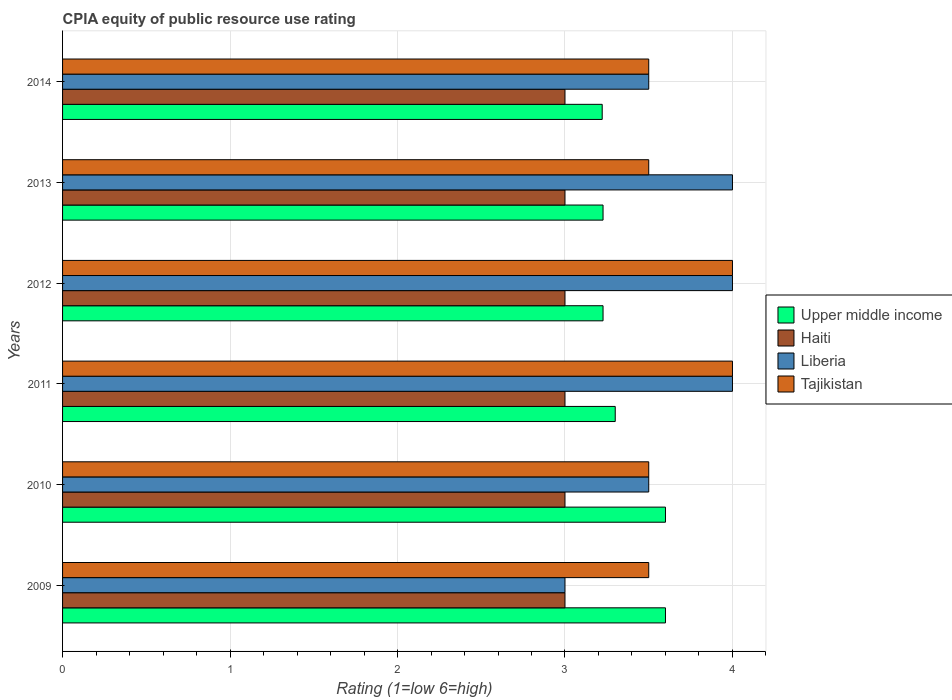How many different coloured bars are there?
Offer a very short reply. 4. How many groups of bars are there?
Ensure brevity in your answer.  6. Are the number of bars per tick equal to the number of legend labels?
Offer a very short reply. Yes. Are the number of bars on each tick of the Y-axis equal?
Your answer should be compact. Yes. How many bars are there on the 5th tick from the top?
Ensure brevity in your answer.  4. How many bars are there on the 2nd tick from the bottom?
Your answer should be very brief. 4. What is the CPIA rating in Tajikistan in 2012?
Provide a succinct answer. 4. Across all years, what is the maximum CPIA rating in Upper middle income?
Ensure brevity in your answer.  3.6. Across all years, what is the minimum CPIA rating in Upper middle income?
Your response must be concise. 3.22. In which year was the CPIA rating in Haiti maximum?
Make the answer very short. 2009. What is the total CPIA rating in Liberia in the graph?
Your answer should be very brief. 22. What is the difference between the CPIA rating in Upper middle income in 2013 and that in 2014?
Offer a terse response. 0.01. In the year 2011, what is the difference between the CPIA rating in Haiti and CPIA rating in Upper middle income?
Offer a very short reply. -0.3. In how many years, is the CPIA rating in Upper middle income greater than 3.6 ?
Keep it short and to the point. 0. What is the ratio of the CPIA rating in Upper middle income in 2012 to that in 2013?
Offer a terse response. 1. Is the CPIA rating in Upper middle income in 2011 less than that in 2012?
Offer a terse response. No. What is the difference between the highest and the second highest CPIA rating in Tajikistan?
Ensure brevity in your answer.  0. What is the difference between the highest and the lowest CPIA rating in Upper middle income?
Your response must be concise. 0.38. In how many years, is the CPIA rating in Tajikistan greater than the average CPIA rating in Tajikistan taken over all years?
Your response must be concise. 2. Is the sum of the CPIA rating in Tajikistan in 2010 and 2011 greater than the maximum CPIA rating in Liberia across all years?
Offer a very short reply. Yes. Is it the case that in every year, the sum of the CPIA rating in Tajikistan and CPIA rating in Liberia is greater than the sum of CPIA rating in Upper middle income and CPIA rating in Haiti?
Offer a very short reply. No. What does the 4th bar from the top in 2013 represents?
Provide a short and direct response. Upper middle income. What does the 2nd bar from the bottom in 2011 represents?
Provide a succinct answer. Haiti. How many years are there in the graph?
Offer a very short reply. 6. Does the graph contain any zero values?
Provide a short and direct response. No. Does the graph contain grids?
Offer a terse response. Yes. Where does the legend appear in the graph?
Your response must be concise. Center right. How many legend labels are there?
Give a very brief answer. 4. How are the legend labels stacked?
Offer a very short reply. Vertical. What is the title of the graph?
Ensure brevity in your answer.  CPIA equity of public resource use rating. Does "Europe(all income levels)" appear as one of the legend labels in the graph?
Offer a very short reply. No. What is the label or title of the X-axis?
Ensure brevity in your answer.  Rating (1=low 6=high). What is the label or title of the Y-axis?
Your answer should be very brief. Years. What is the Rating (1=low 6=high) in Upper middle income in 2009?
Give a very brief answer. 3.6. What is the Rating (1=low 6=high) in Haiti in 2009?
Offer a terse response. 3. What is the Rating (1=low 6=high) of Liberia in 2009?
Make the answer very short. 3. What is the Rating (1=low 6=high) in Tajikistan in 2009?
Your answer should be very brief. 3.5. What is the Rating (1=low 6=high) of Haiti in 2010?
Your response must be concise. 3. What is the Rating (1=low 6=high) of Liberia in 2010?
Offer a terse response. 3.5. What is the Rating (1=low 6=high) of Tajikistan in 2010?
Offer a terse response. 3.5. What is the Rating (1=low 6=high) of Tajikistan in 2011?
Offer a very short reply. 4. What is the Rating (1=low 6=high) of Upper middle income in 2012?
Offer a terse response. 3.23. What is the Rating (1=low 6=high) of Tajikistan in 2012?
Your answer should be very brief. 4. What is the Rating (1=low 6=high) of Upper middle income in 2013?
Offer a very short reply. 3.23. What is the Rating (1=low 6=high) of Liberia in 2013?
Offer a terse response. 4. What is the Rating (1=low 6=high) in Tajikistan in 2013?
Ensure brevity in your answer.  3.5. What is the Rating (1=low 6=high) of Upper middle income in 2014?
Keep it short and to the point. 3.22. What is the Rating (1=low 6=high) in Haiti in 2014?
Your answer should be compact. 3. Across all years, what is the maximum Rating (1=low 6=high) in Upper middle income?
Give a very brief answer. 3.6. Across all years, what is the maximum Rating (1=low 6=high) in Haiti?
Give a very brief answer. 3. Across all years, what is the maximum Rating (1=low 6=high) of Liberia?
Ensure brevity in your answer.  4. Across all years, what is the maximum Rating (1=low 6=high) in Tajikistan?
Ensure brevity in your answer.  4. Across all years, what is the minimum Rating (1=low 6=high) of Upper middle income?
Your answer should be compact. 3.22. Across all years, what is the minimum Rating (1=low 6=high) of Liberia?
Give a very brief answer. 3. Across all years, what is the minimum Rating (1=low 6=high) in Tajikistan?
Provide a short and direct response. 3.5. What is the total Rating (1=low 6=high) of Upper middle income in the graph?
Keep it short and to the point. 20.18. What is the total Rating (1=low 6=high) in Tajikistan in the graph?
Provide a succinct answer. 22. What is the difference between the Rating (1=low 6=high) in Upper middle income in 2009 and that in 2010?
Give a very brief answer. 0. What is the difference between the Rating (1=low 6=high) in Tajikistan in 2009 and that in 2010?
Your response must be concise. 0. What is the difference between the Rating (1=low 6=high) of Upper middle income in 2009 and that in 2011?
Keep it short and to the point. 0.3. What is the difference between the Rating (1=low 6=high) of Haiti in 2009 and that in 2011?
Keep it short and to the point. 0. What is the difference between the Rating (1=low 6=high) in Liberia in 2009 and that in 2011?
Your answer should be compact. -1. What is the difference between the Rating (1=low 6=high) in Tajikistan in 2009 and that in 2011?
Your answer should be compact. -0.5. What is the difference between the Rating (1=low 6=high) in Upper middle income in 2009 and that in 2012?
Provide a succinct answer. 0.37. What is the difference between the Rating (1=low 6=high) of Haiti in 2009 and that in 2012?
Ensure brevity in your answer.  0. What is the difference between the Rating (1=low 6=high) in Liberia in 2009 and that in 2012?
Offer a terse response. -1. What is the difference between the Rating (1=low 6=high) of Tajikistan in 2009 and that in 2012?
Provide a succinct answer. -0.5. What is the difference between the Rating (1=low 6=high) in Upper middle income in 2009 and that in 2013?
Keep it short and to the point. 0.37. What is the difference between the Rating (1=low 6=high) in Haiti in 2009 and that in 2013?
Your answer should be very brief. 0. What is the difference between the Rating (1=low 6=high) in Liberia in 2009 and that in 2013?
Your response must be concise. -1. What is the difference between the Rating (1=low 6=high) in Tajikistan in 2009 and that in 2013?
Your response must be concise. 0. What is the difference between the Rating (1=low 6=high) of Upper middle income in 2009 and that in 2014?
Make the answer very short. 0.38. What is the difference between the Rating (1=low 6=high) of Tajikistan in 2009 and that in 2014?
Your response must be concise. 0. What is the difference between the Rating (1=low 6=high) in Haiti in 2010 and that in 2011?
Provide a short and direct response. 0. What is the difference between the Rating (1=low 6=high) in Liberia in 2010 and that in 2011?
Your response must be concise. -0.5. What is the difference between the Rating (1=low 6=high) of Tajikistan in 2010 and that in 2011?
Give a very brief answer. -0.5. What is the difference between the Rating (1=low 6=high) in Upper middle income in 2010 and that in 2012?
Provide a succinct answer. 0.37. What is the difference between the Rating (1=low 6=high) in Haiti in 2010 and that in 2012?
Offer a very short reply. 0. What is the difference between the Rating (1=low 6=high) of Liberia in 2010 and that in 2012?
Provide a short and direct response. -0.5. What is the difference between the Rating (1=low 6=high) in Upper middle income in 2010 and that in 2013?
Your response must be concise. 0.37. What is the difference between the Rating (1=low 6=high) in Liberia in 2010 and that in 2013?
Offer a very short reply. -0.5. What is the difference between the Rating (1=low 6=high) of Tajikistan in 2010 and that in 2013?
Offer a very short reply. 0. What is the difference between the Rating (1=low 6=high) in Upper middle income in 2010 and that in 2014?
Ensure brevity in your answer.  0.38. What is the difference between the Rating (1=low 6=high) of Haiti in 2010 and that in 2014?
Your response must be concise. 0. What is the difference between the Rating (1=low 6=high) in Liberia in 2010 and that in 2014?
Keep it short and to the point. 0. What is the difference between the Rating (1=low 6=high) of Tajikistan in 2010 and that in 2014?
Your response must be concise. 0. What is the difference between the Rating (1=low 6=high) in Upper middle income in 2011 and that in 2012?
Provide a succinct answer. 0.07. What is the difference between the Rating (1=low 6=high) in Liberia in 2011 and that in 2012?
Make the answer very short. 0. What is the difference between the Rating (1=low 6=high) in Upper middle income in 2011 and that in 2013?
Make the answer very short. 0.07. What is the difference between the Rating (1=low 6=high) of Haiti in 2011 and that in 2013?
Ensure brevity in your answer.  0. What is the difference between the Rating (1=low 6=high) in Upper middle income in 2011 and that in 2014?
Offer a very short reply. 0.08. What is the difference between the Rating (1=low 6=high) of Haiti in 2011 and that in 2014?
Your response must be concise. 0. What is the difference between the Rating (1=low 6=high) in Liberia in 2011 and that in 2014?
Your answer should be compact. 0.5. What is the difference between the Rating (1=low 6=high) in Tajikistan in 2011 and that in 2014?
Your response must be concise. 0.5. What is the difference between the Rating (1=low 6=high) in Upper middle income in 2012 and that in 2013?
Provide a short and direct response. 0. What is the difference between the Rating (1=low 6=high) in Haiti in 2012 and that in 2013?
Your answer should be very brief. 0. What is the difference between the Rating (1=low 6=high) of Tajikistan in 2012 and that in 2013?
Keep it short and to the point. 0.5. What is the difference between the Rating (1=low 6=high) in Upper middle income in 2012 and that in 2014?
Provide a short and direct response. 0.01. What is the difference between the Rating (1=low 6=high) of Tajikistan in 2012 and that in 2014?
Offer a terse response. 0.5. What is the difference between the Rating (1=low 6=high) in Upper middle income in 2013 and that in 2014?
Your response must be concise. 0.01. What is the difference between the Rating (1=low 6=high) of Liberia in 2013 and that in 2014?
Provide a succinct answer. 0.5. What is the difference between the Rating (1=low 6=high) in Upper middle income in 2009 and the Rating (1=low 6=high) in Liberia in 2010?
Your answer should be compact. 0.1. What is the difference between the Rating (1=low 6=high) in Upper middle income in 2009 and the Rating (1=low 6=high) in Tajikistan in 2010?
Provide a short and direct response. 0.1. What is the difference between the Rating (1=low 6=high) in Liberia in 2009 and the Rating (1=low 6=high) in Tajikistan in 2010?
Keep it short and to the point. -0.5. What is the difference between the Rating (1=low 6=high) of Upper middle income in 2009 and the Rating (1=low 6=high) of Liberia in 2011?
Make the answer very short. -0.4. What is the difference between the Rating (1=low 6=high) in Haiti in 2009 and the Rating (1=low 6=high) in Tajikistan in 2011?
Your answer should be compact. -1. What is the difference between the Rating (1=low 6=high) of Upper middle income in 2009 and the Rating (1=low 6=high) of Haiti in 2012?
Your response must be concise. 0.6. What is the difference between the Rating (1=low 6=high) of Liberia in 2009 and the Rating (1=low 6=high) of Tajikistan in 2012?
Make the answer very short. -1. What is the difference between the Rating (1=low 6=high) in Upper middle income in 2009 and the Rating (1=low 6=high) in Haiti in 2013?
Ensure brevity in your answer.  0.6. What is the difference between the Rating (1=low 6=high) of Upper middle income in 2009 and the Rating (1=low 6=high) of Liberia in 2013?
Your response must be concise. -0.4. What is the difference between the Rating (1=low 6=high) in Upper middle income in 2009 and the Rating (1=low 6=high) in Tajikistan in 2013?
Offer a terse response. 0.1. What is the difference between the Rating (1=low 6=high) in Haiti in 2009 and the Rating (1=low 6=high) in Tajikistan in 2013?
Make the answer very short. -0.5. What is the difference between the Rating (1=low 6=high) of Upper middle income in 2009 and the Rating (1=low 6=high) of Tajikistan in 2014?
Make the answer very short. 0.1. What is the difference between the Rating (1=low 6=high) in Haiti in 2009 and the Rating (1=low 6=high) in Liberia in 2014?
Your response must be concise. -0.5. What is the difference between the Rating (1=low 6=high) of Upper middle income in 2010 and the Rating (1=low 6=high) of Haiti in 2011?
Give a very brief answer. 0.6. What is the difference between the Rating (1=low 6=high) of Upper middle income in 2010 and the Rating (1=low 6=high) of Liberia in 2011?
Offer a very short reply. -0.4. What is the difference between the Rating (1=low 6=high) of Liberia in 2010 and the Rating (1=low 6=high) of Tajikistan in 2011?
Your answer should be compact. -0.5. What is the difference between the Rating (1=low 6=high) in Upper middle income in 2010 and the Rating (1=low 6=high) in Liberia in 2012?
Provide a succinct answer. -0.4. What is the difference between the Rating (1=low 6=high) in Upper middle income in 2010 and the Rating (1=low 6=high) in Haiti in 2013?
Your answer should be very brief. 0.6. What is the difference between the Rating (1=low 6=high) of Upper middle income in 2010 and the Rating (1=low 6=high) of Liberia in 2013?
Offer a very short reply. -0.4. What is the difference between the Rating (1=low 6=high) in Haiti in 2010 and the Rating (1=low 6=high) in Liberia in 2013?
Provide a succinct answer. -1. What is the difference between the Rating (1=low 6=high) of Upper middle income in 2010 and the Rating (1=low 6=high) of Liberia in 2014?
Your answer should be very brief. 0.1. What is the difference between the Rating (1=low 6=high) of Upper middle income in 2010 and the Rating (1=low 6=high) of Tajikistan in 2014?
Offer a terse response. 0.1. What is the difference between the Rating (1=low 6=high) in Liberia in 2010 and the Rating (1=low 6=high) in Tajikistan in 2014?
Offer a terse response. 0. What is the difference between the Rating (1=low 6=high) of Upper middle income in 2011 and the Rating (1=low 6=high) of Haiti in 2012?
Your response must be concise. 0.3. What is the difference between the Rating (1=low 6=high) of Haiti in 2011 and the Rating (1=low 6=high) of Liberia in 2012?
Your answer should be compact. -1. What is the difference between the Rating (1=low 6=high) of Upper middle income in 2011 and the Rating (1=low 6=high) of Liberia in 2013?
Your answer should be very brief. -0.7. What is the difference between the Rating (1=low 6=high) of Upper middle income in 2011 and the Rating (1=low 6=high) of Tajikistan in 2013?
Provide a short and direct response. -0.2. What is the difference between the Rating (1=low 6=high) of Liberia in 2011 and the Rating (1=low 6=high) of Tajikistan in 2013?
Your answer should be compact. 0.5. What is the difference between the Rating (1=low 6=high) of Upper middle income in 2011 and the Rating (1=low 6=high) of Liberia in 2014?
Offer a terse response. -0.2. What is the difference between the Rating (1=low 6=high) in Upper middle income in 2011 and the Rating (1=low 6=high) in Tajikistan in 2014?
Your answer should be compact. -0.2. What is the difference between the Rating (1=low 6=high) of Haiti in 2011 and the Rating (1=low 6=high) of Tajikistan in 2014?
Offer a very short reply. -0.5. What is the difference between the Rating (1=low 6=high) of Liberia in 2011 and the Rating (1=low 6=high) of Tajikistan in 2014?
Provide a succinct answer. 0.5. What is the difference between the Rating (1=low 6=high) in Upper middle income in 2012 and the Rating (1=low 6=high) in Haiti in 2013?
Your response must be concise. 0.23. What is the difference between the Rating (1=low 6=high) in Upper middle income in 2012 and the Rating (1=low 6=high) in Liberia in 2013?
Offer a terse response. -0.77. What is the difference between the Rating (1=low 6=high) in Upper middle income in 2012 and the Rating (1=low 6=high) in Tajikistan in 2013?
Offer a very short reply. -0.27. What is the difference between the Rating (1=low 6=high) in Liberia in 2012 and the Rating (1=low 6=high) in Tajikistan in 2013?
Give a very brief answer. 0.5. What is the difference between the Rating (1=low 6=high) of Upper middle income in 2012 and the Rating (1=low 6=high) of Haiti in 2014?
Provide a succinct answer. 0.23. What is the difference between the Rating (1=low 6=high) of Upper middle income in 2012 and the Rating (1=low 6=high) of Liberia in 2014?
Offer a terse response. -0.27. What is the difference between the Rating (1=low 6=high) in Upper middle income in 2012 and the Rating (1=low 6=high) in Tajikistan in 2014?
Your response must be concise. -0.27. What is the difference between the Rating (1=low 6=high) of Haiti in 2012 and the Rating (1=low 6=high) of Liberia in 2014?
Provide a succinct answer. -0.5. What is the difference between the Rating (1=low 6=high) of Haiti in 2012 and the Rating (1=low 6=high) of Tajikistan in 2014?
Give a very brief answer. -0.5. What is the difference between the Rating (1=low 6=high) of Liberia in 2012 and the Rating (1=low 6=high) of Tajikistan in 2014?
Provide a succinct answer. 0.5. What is the difference between the Rating (1=low 6=high) of Upper middle income in 2013 and the Rating (1=low 6=high) of Haiti in 2014?
Provide a short and direct response. 0.23. What is the difference between the Rating (1=low 6=high) in Upper middle income in 2013 and the Rating (1=low 6=high) in Liberia in 2014?
Provide a succinct answer. -0.27. What is the difference between the Rating (1=low 6=high) in Upper middle income in 2013 and the Rating (1=low 6=high) in Tajikistan in 2014?
Make the answer very short. -0.27. What is the difference between the Rating (1=low 6=high) in Haiti in 2013 and the Rating (1=low 6=high) in Liberia in 2014?
Provide a succinct answer. -0.5. What is the difference between the Rating (1=low 6=high) of Liberia in 2013 and the Rating (1=low 6=high) of Tajikistan in 2014?
Provide a succinct answer. 0.5. What is the average Rating (1=low 6=high) in Upper middle income per year?
Keep it short and to the point. 3.36. What is the average Rating (1=low 6=high) of Haiti per year?
Make the answer very short. 3. What is the average Rating (1=low 6=high) in Liberia per year?
Offer a terse response. 3.67. What is the average Rating (1=low 6=high) in Tajikistan per year?
Provide a short and direct response. 3.67. In the year 2009, what is the difference between the Rating (1=low 6=high) of Upper middle income and Rating (1=low 6=high) of Liberia?
Give a very brief answer. 0.6. In the year 2009, what is the difference between the Rating (1=low 6=high) in Upper middle income and Rating (1=low 6=high) in Tajikistan?
Offer a terse response. 0.1. In the year 2009, what is the difference between the Rating (1=low 6=high) in Haiti and Rating (1=low 6=high) in Tajikistan?
Give a very brief answer. -0.5. In the year 2009, what is the difference between the Rating (1=low 6=high) of Liberia and Rating (1=low 6=high) of Tajikistan?
Your answer should be very brief. -0.5. In the year 2010, what is the difference between the Rating (1=low 6=high) of Haiti and Rating (1=low 6=high) of Liberia?
Provide a short and direct response. -0.5. In the year 2010, what is the difference between the Rating (1=low 6=high) in Haiti and Rating (1=low 6=high) in Tajikistan?
Offer a terse response. -0.5. In the year 2011, what is the difference between the Rating (1=low 6=high) in Upper middle income and Rating (1=low 6=high) in Haiti?
Your answer should be compact. 0.3. In the year 2011, what is the difference between the Rating (1=low 6=high) of Upper middle income and Rating (1=low 6=high) of Tajikistan?
Provide a succinct answer. -0.7. In the year 2011, what is the difference between the Rating (1=low 6=high) of Liberia and Rating (1=low 6=high) of Tajikistan?
Ensure brevity in your answer.  0. In the year 2012, what is the difference between the Rating (1=low 6=high) in Upper middle income and Rating (1=low 6=high) in Haiti?
Make the answer very short. 0.23. In the year 2012, what is the difference between the Rating (1=low 6=high) of Upper middle income and Rating (1=low 6=high) of Liberia?
Your answer should be very brief. -0.77. In the year 2012, what is the difference between the Rating (1=low 6=high) of Upper middle income and Rating (1=low 6=high) of Tajikistan?
Offer a very short reply. -0.77. In the year 2012, what is the difference between the Rating (1=low 6=high) of Haiti and Rating (1=low 6=high) of Liberia?
Your answer should be compact. -1. In the year 2012, what is the difference between the Rating (1=low 6=high) of Haiti and Rating (1=low 6=high) of Tajikistan?
Offer a terse response. -1. In the year 2012, what is the difference between the Rating (1=low 6=high) of Liberia and Rating (1=low 6=high) of Tajikistan?
Provide a short and direct response. 0. In the year 2013, what is the difference between the Rating (1=low 6=high) in Upper middle income and Rating (1=low 6=high) in Haiti?
Your answer should be compact. 0.23. In the year 2013, what is the difference between the Rating (1=low 6=high) in Upper middle income and Rating (1=low 6=high) in Liberia?
Your answer should be very brief. -0.77. In the year 2013, what is the difference between the Rating (1=low 6=high) of Upper middle income and Rating (1=low 6=high) of Tajikistan?
Offer a terse response. -0.27. In the year 2013, what is the difference between the Rating (1=low 6=high) in Haiti and Rating (1=low 6=high) in Liberia?
Your answer should be very brief. -1. In the year 2014, what is the difference between the Rating (1=low 6=high) of Upper middle income and Rating (1=low 6=high) of Haiti?
Your answer should be very brief. 0.22. In the year 2014, what is the difference between the Rating (1=low 6=high) in Upper middle income and Rating (1=low 6=high) in Liberia?
Keep it short and to the point. -0.28. In the year 2014, what is the difference between the Rating (1=low 6=high) of Upper middle income and Rating (1=low 6=high) of Tajikistan?
Provide a short and direct response. -0.28. In the year 2014, what is the difference between the Rating (1=low 6=high) in Liberia and Rating (1=low 6=high) in Tajikistan?
Your answer should be very brief. 0. What is the ratio of the Rating (1=low 6=high) in Liberia in 2009 to that in 2010?
Give a very brief answer. 0.86. What is the ratio of the Rating (1=low 6=high) in Tajikistan in 2009 to that in 2010?
Your answer should be compact. 1. What is the ratio of the Rating (1=low 6=high) of Upper middle income in 2009 to that in 2011?
Offer a very short reply. 1.09. What is the ratio of the Rating (1=low 6=high) in Haiti in 2009 to that in 2011?
Keep it short and to the point. 1. What is the ratio of the Rating (1=low 6=high) in Liberia in 2009 to that in 2011?
Your answer should be compact. 0.75. What is the ratio of the Rating (1=low 6=high) of Tajikistan in 2009 to that in 2011?
Provide a succinct answer. 0.88. What is the ratio of the Rating (1=low 6=high) in Upper middle income in 2009 to that in 2012?
Ensure brevity in your answer.  1.12. What is the ratio of the Rating (1=low 6=high) in Liberia in 2009 to that in 2012?
Provide a short and direct response. 0.75. What is the ratio of the Rating (1=low 6=high) in Tajikistan in 2009 to that in 2012?
Keep it short and to the point. 0.88. What is the ratio of the Rating (1=low 6=high) of Upper middle income in 2009 to that in 2013?
Offer a terse response. 1.12. What is the ratio of the Rating (1=low 6=high) in Haiti in 2009 to that in 2013?
Offer a very short reply. 1. What is the ratio of the Rating (1=low 6=high) of Tajikistan in 2009 to that in 2013?
Your answer should be very brief. 1. What is the ratio of the Rating (1=low 6=high) in Upper middle income in 2009 to that in 2014?
Ensure brevity in your answer.  1.12. What is the ratio of the Rating (1=low 6=high) in Haiti in 2009 to that in 2014?
Ensure brevity in your answer.  1. What is the ratio of the Rating (1=low 6=high) in Liberia in 2009 to that in 2014?
Your answer should be very brief. 0.86. What is the ratio of the Rating (1=low 6=high) in Upper middle income in 2010 to that in 2011?
Give a very brief answer. 1.09. What is the ratio of the Rating (1=low 6=high) in Upper middle income in 2010 to that in 2012?
Offer a terse response. 1.12. What is the ratio of the Rating (1=low 6=high) in Liberia in 2010 to that in 2012?
Ensure brevity in your answer.  0.88. What is the ratio of the Rating (1=low 6=high) of Tajikistan in 2010 to that in 2012?
Provide a succinct answer. 0.88. What is the ratio of the Rating (1=low 6=high) in Upper middle income in 2010 to that in 2013?
Offer a very short reply. 1.12. What is the ratio of the Rating (1=low 6=high) of Tajikistan in 2010 to that in 2013?
Your response must be concise. 1. What is the ratio of the Rating (1=low 6=high) in Upper middle income in 2010 to that in 2014?
Offer a very short reply. 1.12. What is the ratio of the Rating (1=low 6=high) in Haiti in 2010 to that in 2014?
Keep it short and to the point. 1. What is the ratio of the Rating (1=low 6=high) of Upper middle income in 2011 to that in 2012?
Keep it short and to the point. 1.02. What is the ratio of the Rating (1=low 6=high) of Liberia in 2011 to that in 2012?
Give a very brief answer. 1. What is the ratio of the Rating (1=low 6=high) of Tajikistan in 2011 to that in 2012?
Your answer should be very brief. 1. What is the ratio of the Rating (1=low 6=high) in Upper middle income in 2011 to that in 2013?
Provide a short and direct response. 1.02. What is the ratio of the Rating (1=low 6=high) of Liberia in 2011 to that in 2013?
Offer a terse response. 1. What is the ratio of the Rating (1=low 6=high) of Tajikistan in 2011 to that in 2013?
Your response must be concise. 1.14. What is the ratio of the Rating (1=low 6=high) of Upper middle income in 2011 to that in 2014?
Your answer should be compact. 1.02. What is the ratio of the Rating (1=low 6=high) of Haiti in 2011 to that in 2014?
Your response must be concise. 1. What is the ratio of the Rating (1=low 6=high) in Liberia in 2011 to that in 2014?
Provide a short and direct response. 1.14. What is the ratio of the Rating (1=low 6=high) in Upper middle income in 2012 to that in 2013?
Ensure brevity in your answer.  1. What is the ratio of the Rating (1=low 6=high) of Liberia in 2012 to that in 2013?
Give a very brief answer. 1. What is the ratio of the Rating (1=low 6=high) in Tajikistan in 2012 to that in 2013?
Your response must be concise. 1.14. What is the ratio of the Rating (1=low 6=high) in Upper middle income in 2012 to that in 2014?
Offer a terse response. 1. What is the ratio of the Rating (1=low 6=high) of Haiti in 2012 to that in 2014?
Your answer should be compact. 1. What is the ratio of the Rating (1=low 6=high) in Liberia in 2012 to that in 2014?
Your answer should be compact. 1.14. What is the ratio of the Rating (1=low 6=high) of Tajikistan in 2012 to that in 2014?
Offer a very short reply. 1.14. What is the ratio of the Rating (1=low 6=high) of Upper middle income in 2013 to that in 2014?
Keep it short and to the point. 1. What is the ratio of the Rating (1=low 6=high) of Haiti in 2013 to that in 2014?
Your answer should be very brief. 1. What is the ratio of the Rating (1=low 6=high) of Tajikistan in 2013 to that in 2014?
Your response must be concise. 1. What is the difference between the highest and the second highest Rating (1=low 6=high) of Upper middle income?
Keep it short and to the point. 0. What is the difference between the highest and the second highest Rating (1=low 6=high) in Haiti?
Ensure brevity in your answer.  0. What is the difference between the highest and the second highest Rating (1=low 6=high) in Liberia?
Your answer should be compact. 0. What is the difference between the highest and the lowest Rating (1=low 6=high) in Upper middle income?
Offer a terse response. 0.38. What is the difference between the highest and the lowest Rating (1=low 6=high) of Liberia?
Provide a succinct answer. 1. 